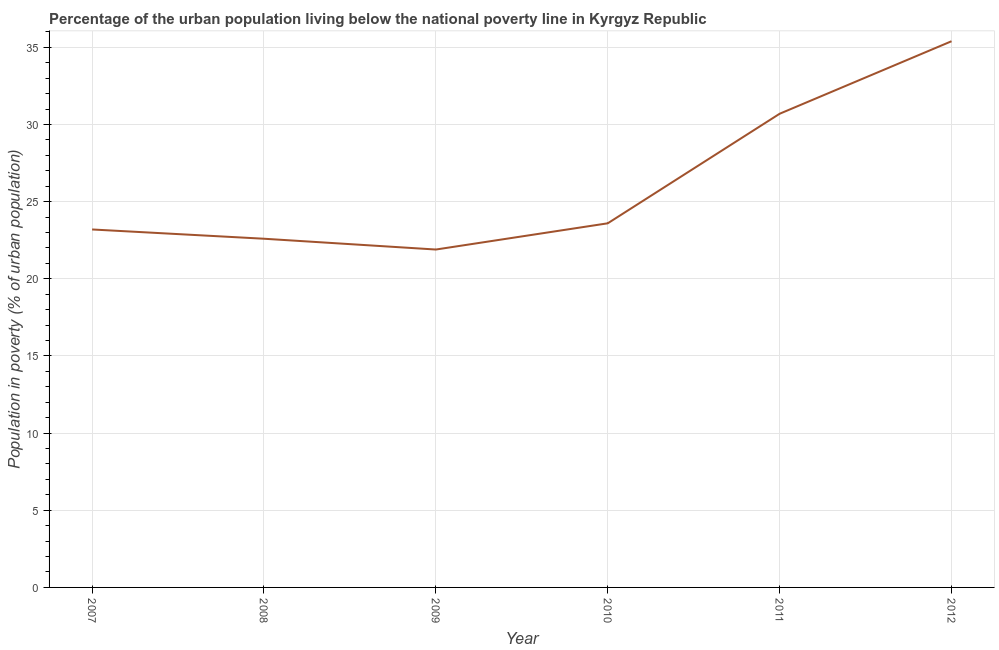What is the percentage of urban population living below poverty line in 2008?
Ensure brevity in your answer.  22.6. Across all years, what is the maximum percentage of urban population living below poverty line?
Provide a succinct answer. 35.4. Across all years, what is the minimum percentage of urban population living below poverty line?
Give a very brief answer. 21.9. In which year was the percentage of urban population living below poverty line maximum?
Offer a very short reply. 2012. What is the sum of the percentage of urban population living below poverty line?
Give a very brief answer. 157.4. What is the difference between the percentage of urban population living below poverty line in 2010 and 2012?
Keep it short and to the point. -11.8. What is the average percentage of urban population living below poverty line per year?
Your answer should be very brief. 26.23. What is the median percentage of urban population living below poverty line?
Give a very brief answer. 23.4. In how many years, is the percentage of urban population living below poverty line greater than 3 %?
Make the answer very short. 6. What is the ratio of the percentage of urban population living below poverty line in 2007 to that in 2008?
Make the answer very short. 1.03. Is the percentage of urban population living below poverty line in 2007 less than that in 2008?
Your answer should be very brief. No. What is the difference between the highest and the second highest percentage of urban population living below poverty line?
Provide a succinct answer. 4.7. What is the difference between the highest and the lowest percentage of urban population living below poverty line?
Provide a succinct answer. 13.5. In how many years, is the percentage of urban population living below poverty line greater than the average percentage of urban population living below poverty line taken over all years?
Keep it short and to the point. 2. How many years are there in the graph?
Your answer should be compact. 6. What is the difference between two consecutive major ticks on the Y-axis?
Give a very brief answer. 5. Does the graph contain grids?
Offer a very short reply. Yes. What is the title of the graph?
Keep it short and to the point. Percentage of the urban population living below the national poverty line in Kyrgyz Republic. What is the label or title of the X-axis?
Make the answer very short. Year. What is the label or title of the Y-axis?
Provide a short and direct response. Population in poverty (% of urban population). What is the Population in poverty (% of urban population) in 2007?
Your answer should be compact. 23.2. What is the Population in poverty (% of urban population) of 2008?
Provide a succinct answer. 22.6. What is the Population in poverty (% of urban population) of 2009?
Ensure brevity in your answer.  21.9. What is the Population in poverty (% of urban population) of 2010?
Give a very brief answer. 23.6. What is the Population in poverty (% of urban population) of 2011?
Make the answer very short. 30.7. What is the Population in poverty (% of urban population) in 2012?
Keep it short and to the point. 35.4. What is the difference between the Population in poverty (% of urban population) in 2007 and 2011?
Ensure brevity in your answer.  -7.5. What is the difference between the Population in poverty (% of urban population) in 2008 and 2010?
Ensure brevity in your answer.  -1. What is the difference between the Population in poverty (% of urban population) in 2008 and 2011?
Your answer should be very brief. -8.1. What is the difference between the Population in poverty (% of urban population) in 2009 and 2012?
Give a very brief answer. -13.5. What is the difference between the Population in poverty (% of urban population) in 2010 and 2012?
Offer a very short reply. -11.8. What is the difference between the Population in poverty (% of urban population) in 2011 and 2012?
Offer a very short reply. -4.7. What is the ratio of the Population in poverty (% of urban population) in 2007 to that in 2009?
Provide a succinct answer. 1.06. What is the ratio of the Population in poverty (% of urban population) in 2007 to that in 2011?
Give a very brief answer. 0.76. What is the ratio of the Population in poverty (% of urban population) in 2007 to that in 2012?
Your response must be concise. 0.66. What is the ratio of the Population in poverty (% of urban population) in 2008 to that in 2009?
Keep it short and to the point. 1.03. What is the ratio of the Population in poverty (% of urban population) in 2008 to that in 2010?
Provide a short and direct response. 0.96. What is the ratio of the Population in poverty (% of urban population) in 2008 to that in 2011?
Ensure brevity in your answer.  0.74. What is the ratio of the Population in poverty (% of urban population) in 2008 to that in 2012?
Offer a terse response. 0.64. What is the ratio of the Population in poverty (% of urban population) in 2009 to that in 2010?
Your response must be concise. 0.93. What is the ratio of the Population in poverty (% of urban population) in 2009 to that in 2011?
Offer a terse response. 0.71. What is the ratio of the Population in poverty (% of urban population) in 2009 to that in 2012?
Give a very brief answer. 0.62. What is the ratio of the Population in poverty (% of urban population) in 2010 to that in 2011?
Ensure brevity in your answer.  0.77. What is the ratio of the Population in poverty (% of urban population) in 2010 to that in 2012?
Make the answer very short. 0.67. What is the ratio of the Population in poverty (% of urban population) in 2011 to that in 2012?
Provide a short and direct response. 0.87. 